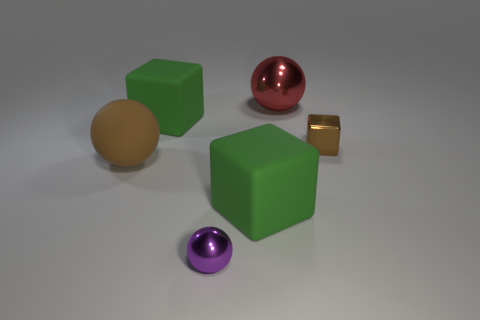Add 1 small gray shiny blocks. How many objects exist? 7 Subtract all rubber balls. How many balls are left? 2 Subtract 1 cubes. How many cubes are left? 2 Subtract all brown blocks. How many blocks are left? 2 Subtract all green spheres. Subtract all brown cylinders. How many spheres are left? 3 Subtract all cyan balls. How many green cubes are left? 2 Subtract all big brown matte balls. Subtract all big green rubber things. How many objects are left? 3 Add 6 brown objects. How many brown objects are left? 8 Add 2 tiny shiny balls. How many tiny shiny balls exist? 3 Subtract 1 brown balls. How many objects are left? 5 